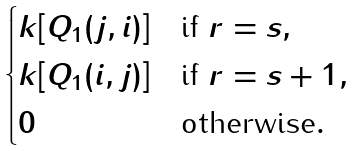<formula> <loc_0><loc_0><loc_500><loc_500>\begin{cases} k [ Q _ { 1 } ( j , i ) ] & \text {if } r = s , \\ k [ Q _ { 1 } ( i , j ) ] & \text {if } r = s + 1 , \\ 0 & \text {otherwise} . \end{cases}</formula> 